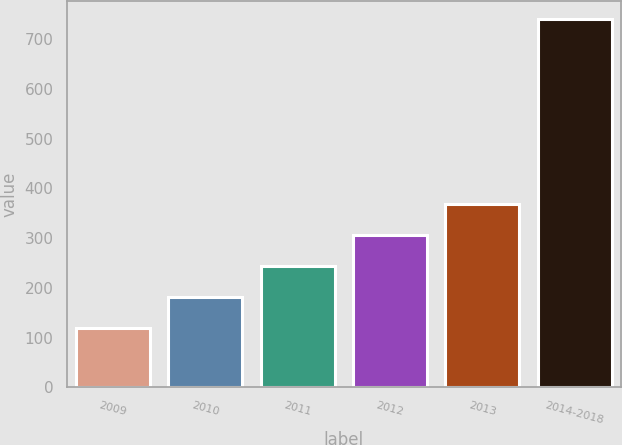Convert chart to OTSL. <chart><loc_0><loc_0><loc_500><loc_500><bar_chart><fcel>2009<fcel>2010<fcel>2011<fcel>2012<fcel>2013<fcel>2014-2018<nl><fcel>120<fcel>182<fcel>244<fcel>306<fcel>368<fcel>740<nl></chart> 